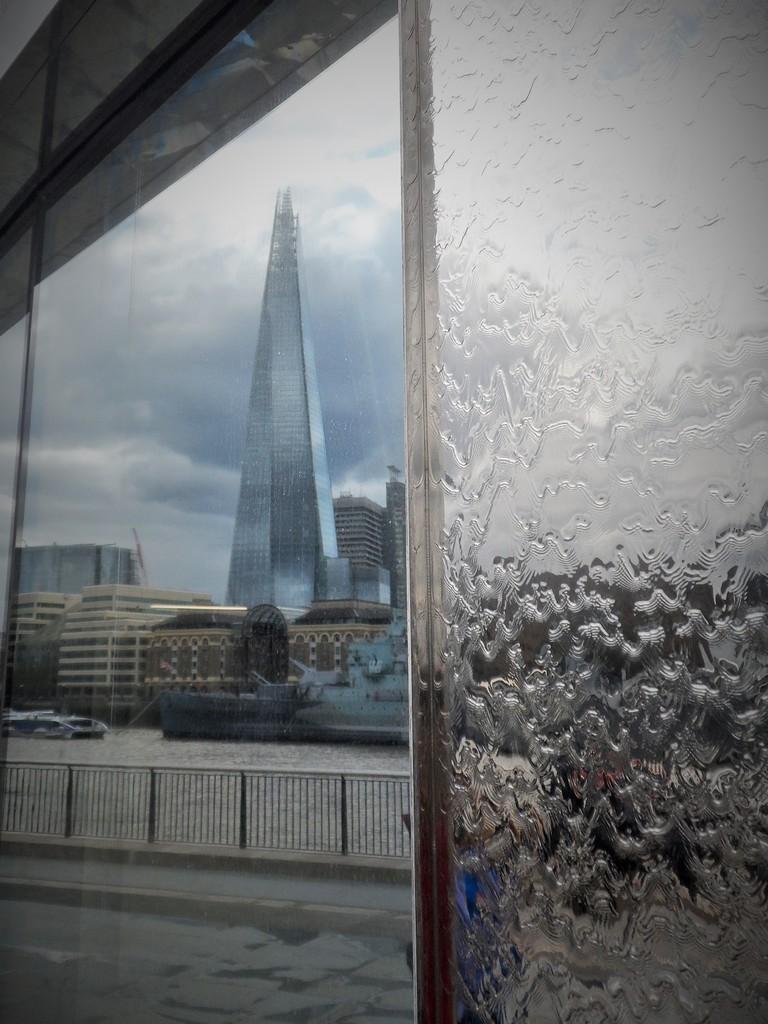Please provide a concise description of this image. This picture seems to be clicked inside. On the right we can see the water on the glass. In the center we can see the deck rail. In the background we can see the sky, skyscrapers, buildings and some objects in the water body. 